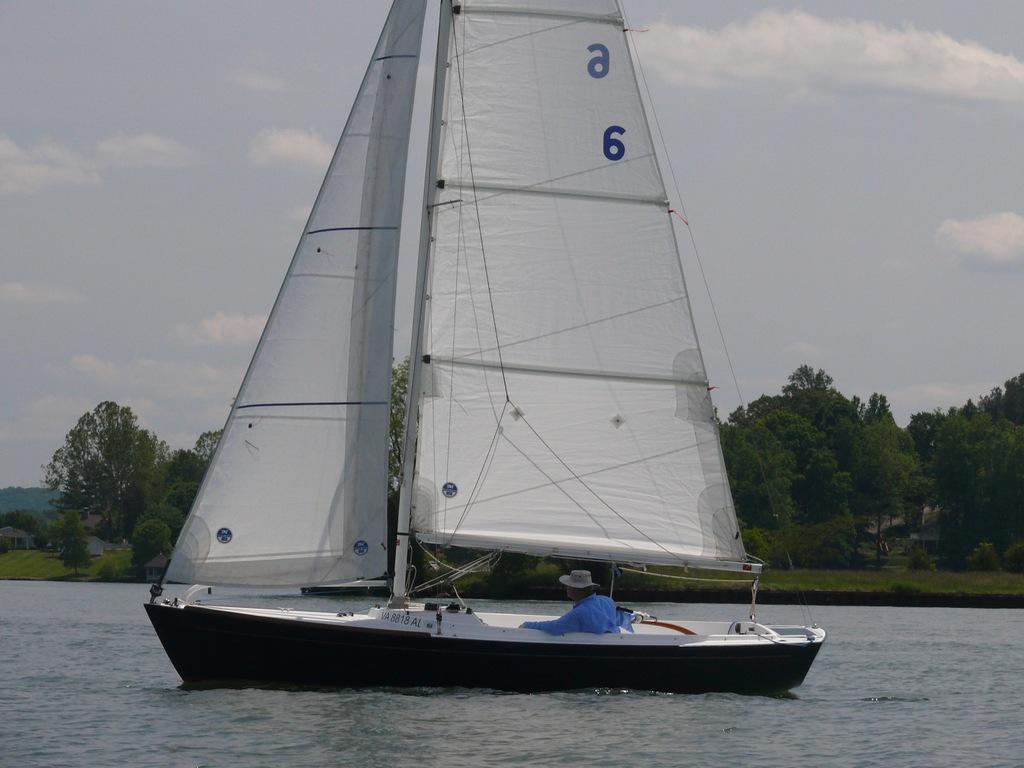<image>
Summarize the visual content of the image. A man sits in a sailboat with white sails with number 6 on them. 